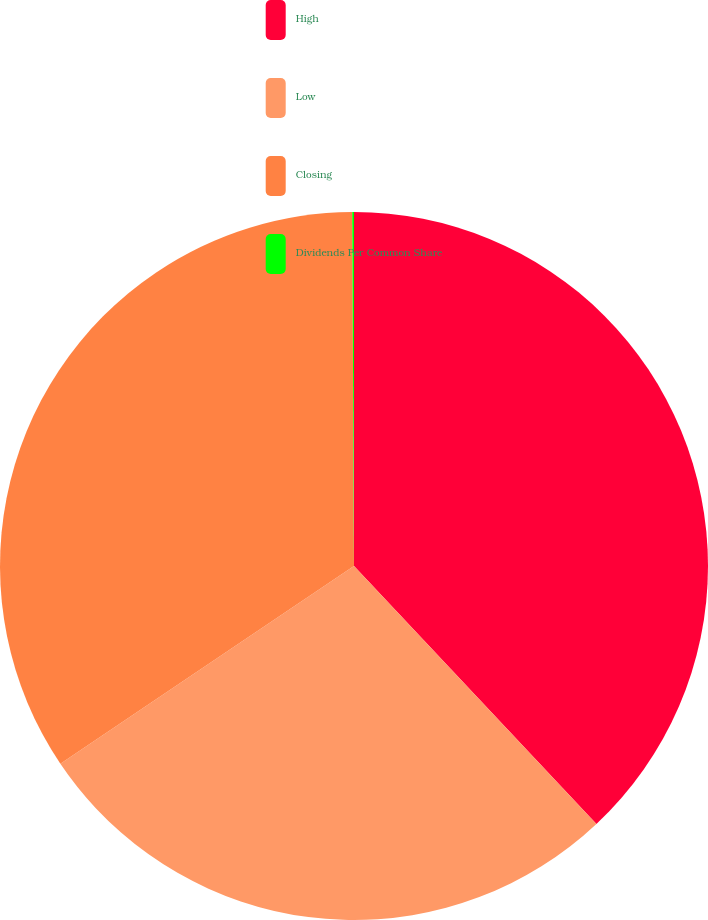<chart> <loc_0><loc_0><loc_500><loc_500><pie_chart><fcel>High<fcel>Low<fcel>Closing<fcel>Dividends Per Common Share<nl><fcel>37.99%<fcel>27.57%<fcel>34.35%<fcel>0.08%<nl></chart> 